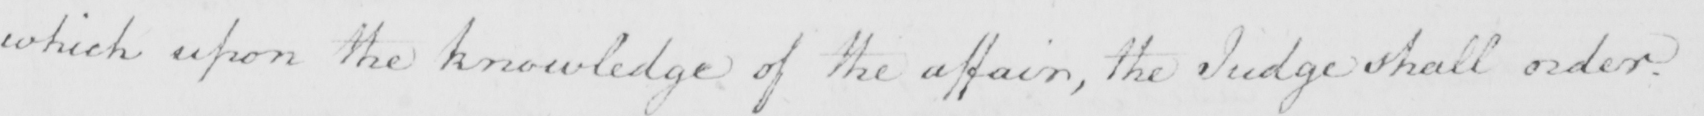What does this handwritten line say? which upon the knowledge of the affair , the Judge shall order . 